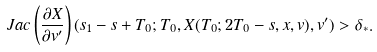Convert formula to latex. <formula><loc_0><loc_0><loc_500><loc_500>J a c \left ( \frac { \partial X } { \partial v ^ { \prime } } \right ) ( s _ { 1 } - s + T _ { 0 } ; T _ { 0 } , X ( T _ { 0 } ; 2 T _ { 0 } - s , x , v ) , v ^ { \prime } ) > \delta _ { * } .</formula> 